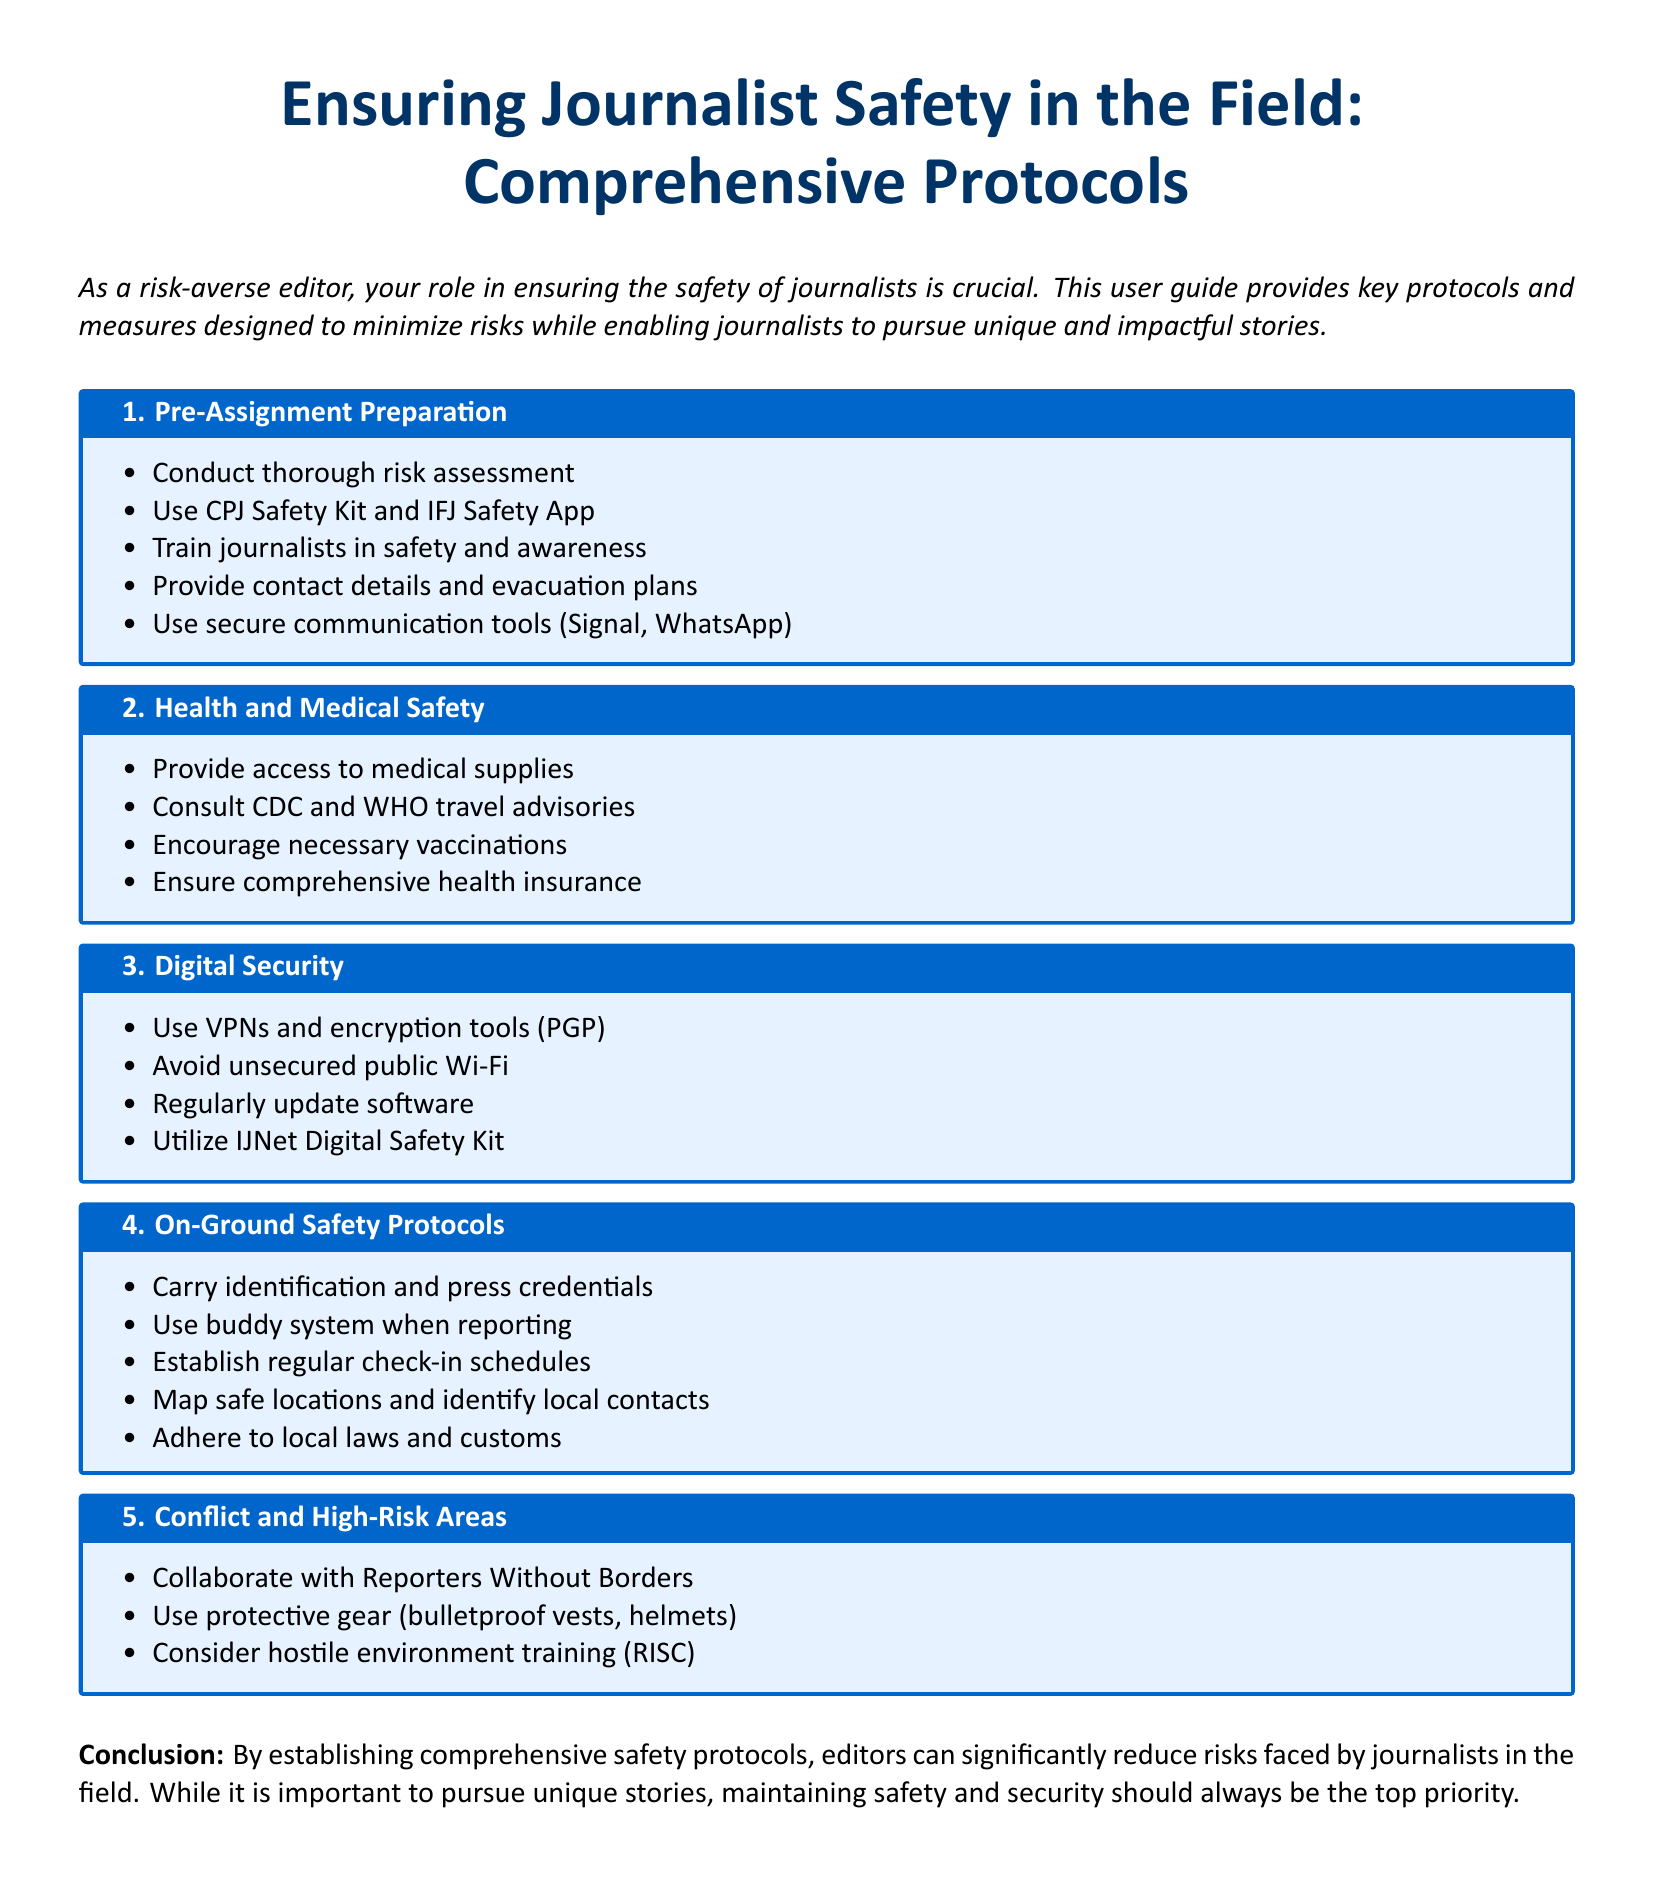What is the title of the document? The title is prominently displayed at the beginning of the document, stating the main focus on journalist safety.
Answer: Ensuring Journalist Safety in the Field: Comprehensive Protocols How many main sections are in the document? The document contains five main sections, each focusing on different safety protocols.
Answer: 5 What is the purpose of the CPJ Safety Kit? The document suggests using the CPJ Safety Kit for thorough risk assessment and preparation before assignments.
Answer: Risk assessment What type of gear is recommended for conflict areas? The section on conflict and high-risk areas outlines specific protective gear that should be used for safety.
Answer: Bulletproof vests, helmets Which organization should journalists collaborate with in high-risk areas? The document specifically mentions an organization that supports journalists in conflict zones.
Answer: Reporters Without Borders What tool does the document recommend for secure communication? The document lists secure communication tools that journalists should use to ensure safety during assignments.
Answer: Signal What medical supplies are emphasized in the health and medical safety section? The document highlights the importance of having certain supplies for health and safety during reporting.
Answer: Access to medical supplies What is included in the on-ground safety protocols? The document outlines multiple safety measures for journalists while on the ground.
Answer: Establish regular check-in schedules What type of training is suggested for high-risk environments? The document recommends undergoing a specific type of training for journalists working in dangerous situations.
Answer: Hostile environment training (RISC) 